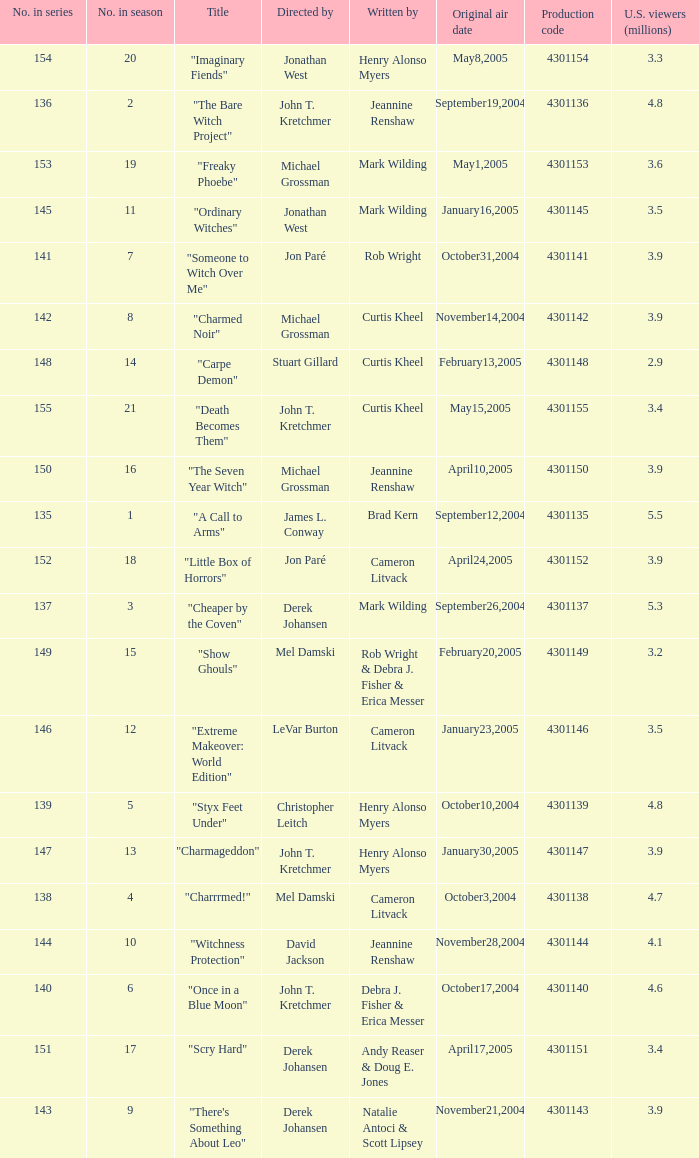Who were the directors of the episode called "someone to witch over me"? Jon Paré. 